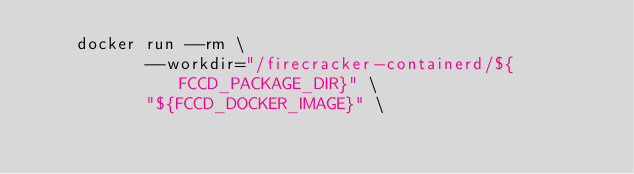<code> <loc_0><loc_0><loc_500><loc_500><_Bash_>    docker run --rm \
           --workdir="/firecracker-containerd/${FCCD_PACKAGE_DIR}" \
           "${FCCD_DOCKER_IMAGE}" \</code> 